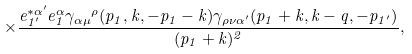Convert formula to latex. <formula><loc_0><loc_0><loc_500><loc_500>\times \frac { e _ { 1 ^ { \prime } } ^ { * \alpha ^ { \prime } } e _ { 1 } ^ { \alpha } { \gamma _ { \alpha \mu } } ^ { \rho } ( p _ { 1 } , k , - p _ { 1 } - k ) \gamma _ { \rho \nu \alpha ^ { \prime } } ( p _ { 1 } + k , k - q , - p _ { 1 ^ { \prime } } ) } { ( p _ { 1 } + k ) ^ { 2 } } ,</formula> 